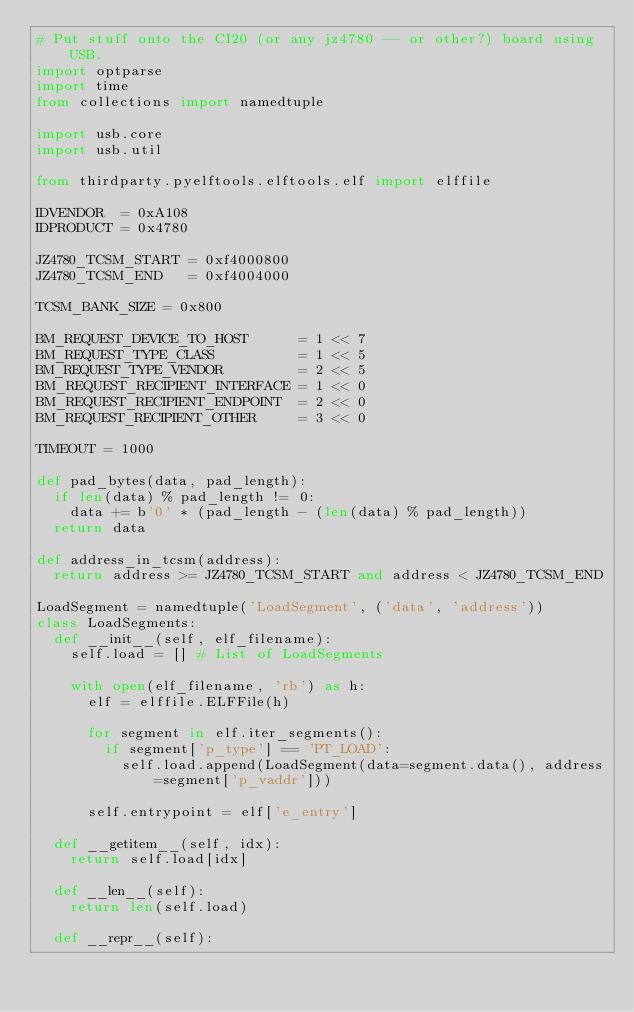<code> <loc_0><loc_0><loc_500><loc_500><_Python_># Put stuff onto the CI20 (or any jz4780 -- or other?) board using USB.
import optparse
import time
from collections import namedtuple

import usb.core
import usb.util

from thirdparty.pyelftools.elftools.elf import elffile

IDVENDOR  = 0xA108
IDPRODUCT = 0x4780

JZ4780_TCSM_START = 0xf4000800
JZ4780_TCSM_END   = 0xf4004000

TCSM_BANK_SIZE = 0x800

BM_REQUEST_DEVICE_TO_HOST      = 1 << 7
BM_REQUEST_TYPE_CLASS          = 1 << 5
BM_REQUEST_TYPE_VENDOR         = 2 << 5
BM_REQUEST_RECIPIENT_INTERFACE = 1 << 0
BM_REQUEST_RECIPIENT_ENDPOINT  = 2 << 0
BM_REQUEST_RECIPIENT_OTHER     = 3 << 0

TIMEOUT = 1000

def pad_bytes(data, pad_length):
	if len(data) % pad_length != 0:
		data += b'0' * (pad_length - (len(data) % pad_length))
	return data

def address_in_tcsm(address):
	return address >= JZ4780_TCSM_START and address < JZ4780_TCSM_END

LoadSegment = namedtuple('LoadSegment', ('data', 'address'))
class LoadSegments:
	def __init__(self, elf_filename):
		self.load = [] # List of LoadSegments

		with open(elf_filename, 'rb') as h:
			elf = elffile.ELFFile(h)

			for segment in elf.iter_segments():
				if segment['p_type'] == 'PT_LOAD':
					self.load.append(LoadSegment(data=segment.data(), address=segment['p_vaddr']))

			self.entrypoint = elf['e_entry']
	
	def __getitem__(self, idx):
		return self.load[idx]

	def __len__(self):
		return len(self.load)

	def __repr__(self):</code> 